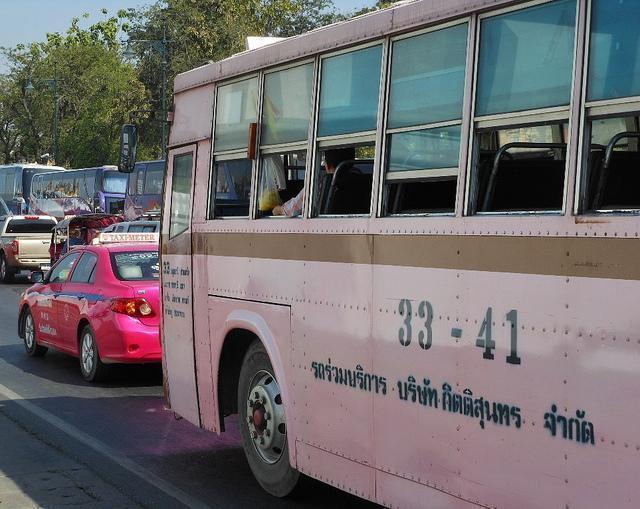What continent is this road located at?
Choose the right answer and clarify with the format: 'Answer: answer
Rationale: rationale.'
Options: Europe, africa, asia, australia. Answer: asia.
Rationale: The bus has filipino writing on it. the philippines are in asia. 